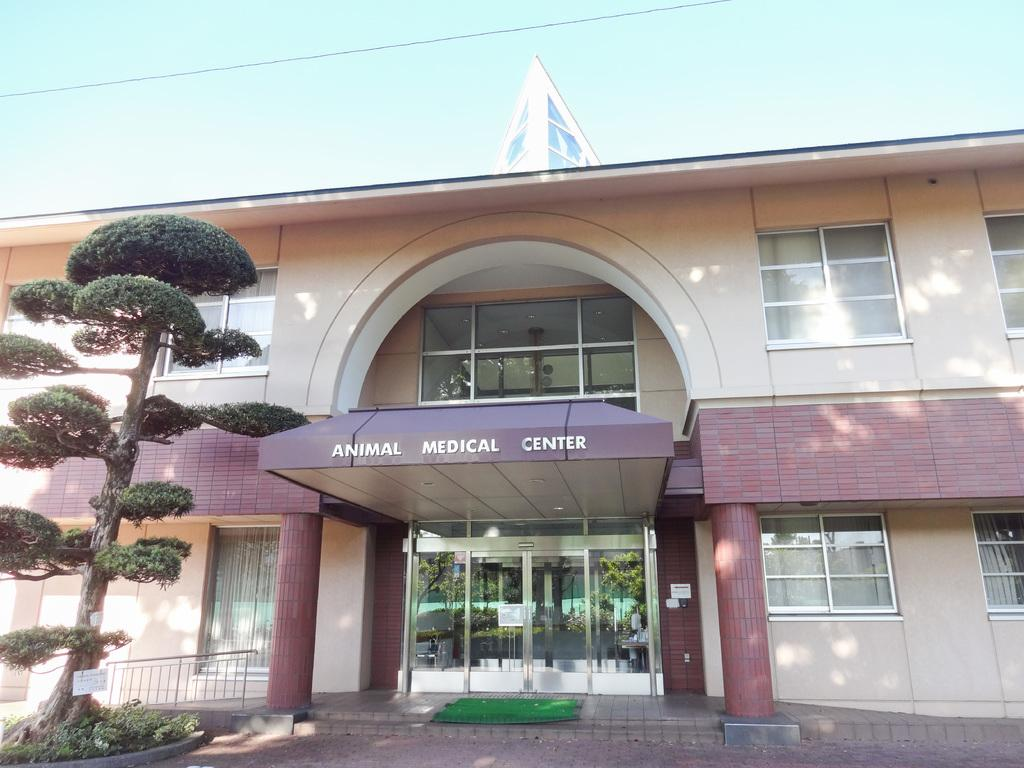<image>
Give a short and clear explanation of the subsequent image. A big building of Animal medical center with a big tree on the left side. 